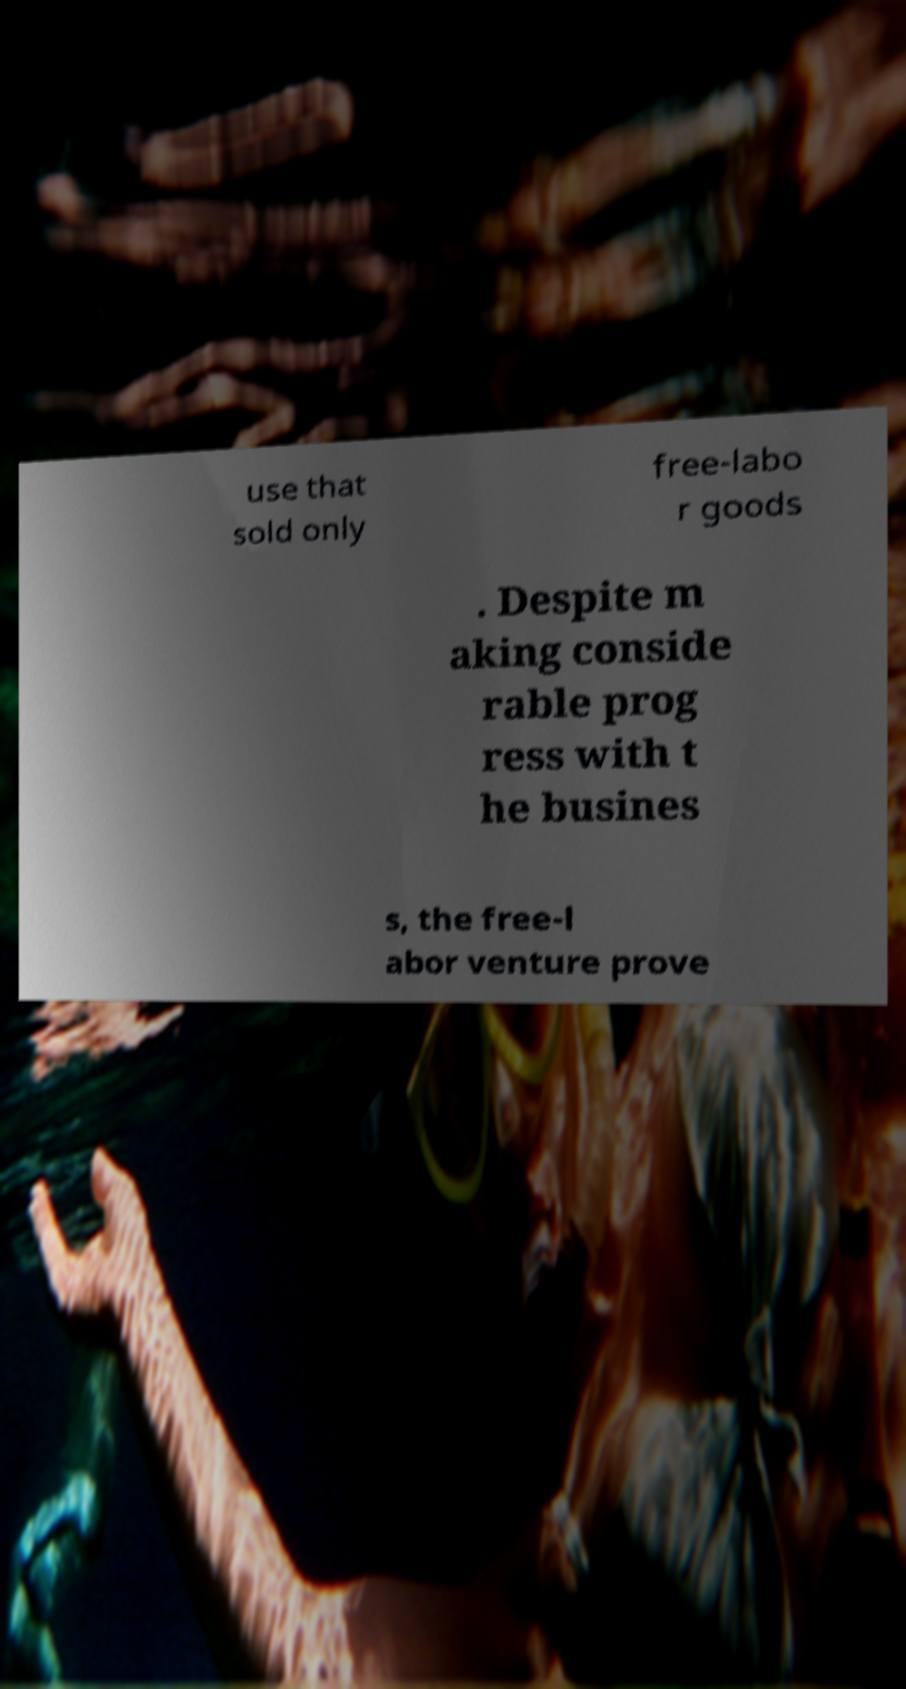There's text embedded in this image that I need extracted. Can you transcribe it verbatim? use that sold only free-labo r goods . Despite m aking conside rable prog ress with t he busines s, the free-l abor venture prove 